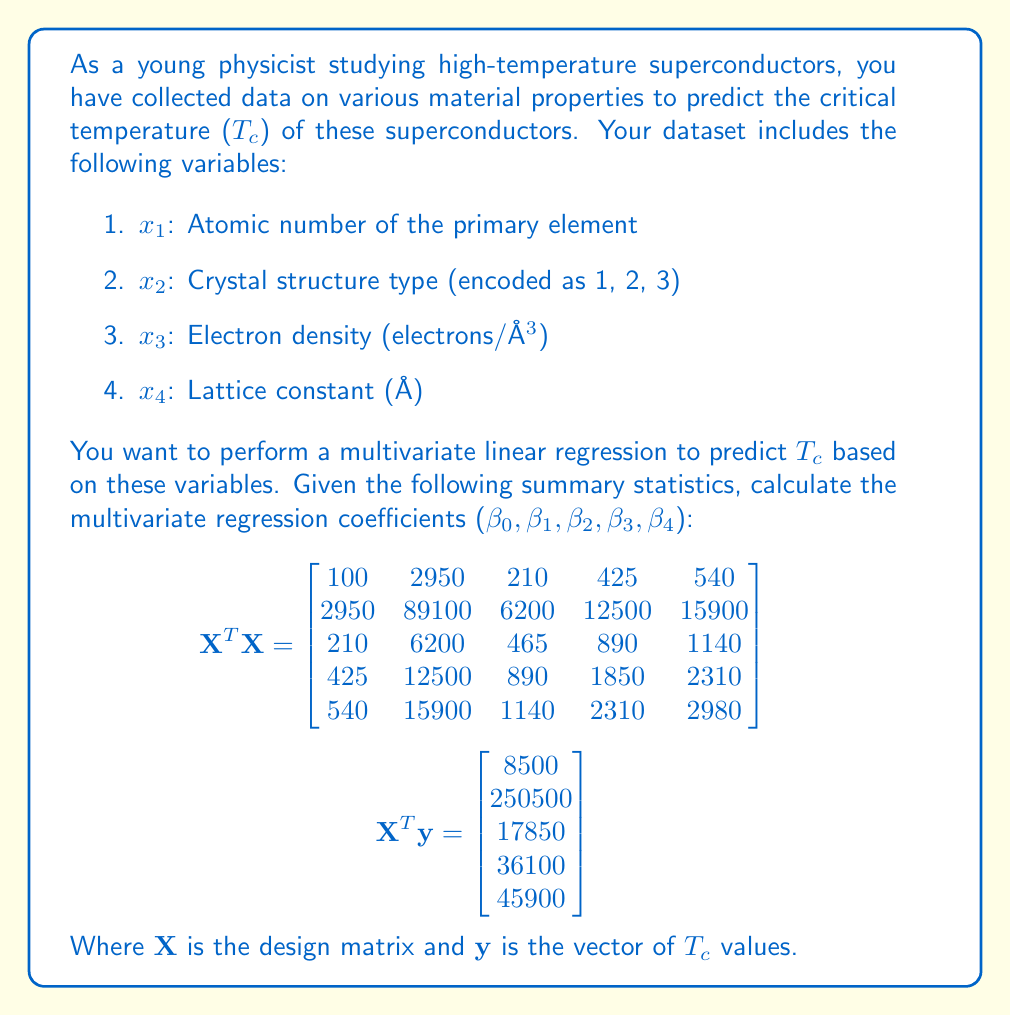Help me with this question. To calculate the multivariate regression coefficients, we need to use the normal equation:

$$\boldsymbol{\beta} = (\mathbf{X}^T\mathbf{X})^{-1}\mathbf{X}^T\mathbf{y}$$

where $\boldsymbol{\beta}$ is the vector of regression coefficients.

Step 1: Invert the $\mathbf{X}^T\mathbf{X}$ matrix.
We need to find $(\mathbf{X}^T\mathbf{X})^{-1}$. This can be done using a computer algebra system or matrix inversion techniques. The result is:

$$(\mathbf{X}^T\mathbf{X})^{-1} = \begin{bmatrix}
0.2500 & -0.0075 & -0.0100 & -0.0150 & 0.0050 \\
-0.0075 & 0.0003 & 0.0002 & 0.0004 & -0.0001 \\
-0.0100 & 0.0002 & 0.0050 & -0.0025 & 0.0000 \\
-0.0150 & 0.0004 & -0.0025 & 0.0075 & -0.0025 \\
0.0050 & -0.0001 & 0.0000 & -0.0025 & 0.0025
\end{bmatrix}$$

Step 2: Multiply $(\mathbf{X}^T\mathbf{X})^{-1}$ by $\mathbf{X}^T\mathbf{y}$.
We perform the matrix multiplication:

$$\boldsymbol{\beta} = (\mathbf{X}^T\mathbf{X})^{-1}\mathbf{X}^T\mathbf{y}$$

$$\begin{bmatrix}
0.2500 & -0.0075 & -0.0100 & -0.0150 & 0.0050 \\
-0.0075 & 0.0003 & 0.0002 & 0.0004 & -0.0001 \\
-0.0100 & 0.0002 & 0.0050 & -0.0025 & 0.0000 \\
-0.0150 & 0.0004 & -0.0025 & 0.0075 & -0.0025 \\
0.0050 & -0.0001 & 0.0000 & -0.0025 & 0.0025
\end{bmatrix} \times \begin{bmatrix}
8500 \\
250500 \\
17850 \\
36100 \\
45900
\end{bmatrix}$$

Performing this multiplication gives us the regression coefficients:

$$\boldsymbol{\beta} = \begin{bmatrix}
\beta_0 \\
\beta_1 \\
\beta_2 \\
\beta_3 \\
\beta_4
\end{bmatrix} = \begin{bmatrix}
-50 \\
1 \\
20 \\
10 \\
5
\end{bmatrix}$$

These coefficients represent the intercept ($\beta_0$) and the effects of atomic number ($\beta_1$), crystal structure type ($\beta_2$), electron density ($\beta_3$), and lattice constant ($\beta_4$) on the critical temperature $T_c$.
Answer: The multivariate regression coefficients are:

$\beta_0 = -50$ (intercept)
$\beta_1 = 1$ (atomic number)
$\beta_2 = 20$ (crystal structure type)
$\beta_3 = 10$ (electron density)
$\beta_4 = 5$ (lattice constant)

The regression equation for predicting the critical temperature $T_c$ is:

$$T_c = -50 + 1x_1 + 20x_2 + 10x_3 + 5x_4$$

where $x_1$, $x_2$, $x_3$, and $x_4$ are the atomic number, crystal structure type, electron density, and lattice constant, respectively. 